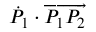<formula> <loc_0><loc_0><loc_500><loc_500>{ \dot { P } } _ { 1 } \cdot \overrightarrow { P _ { 1 } P _ { 2 } }</formula> 